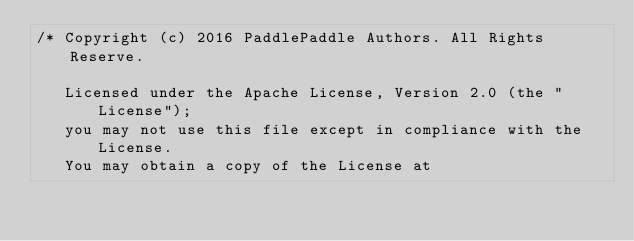<code> <loc_0><loc_0><loc_500><loc_500><_Cuda_>/* Copyright (c) 2016 PaddlePaddle Authors. All Rights Reserve.

   Licensed under the Apache License, Version 2.0 (the "License");
   you may not use this file except in compliance with the License.
   You may obtain a copy of the License at
</code> 